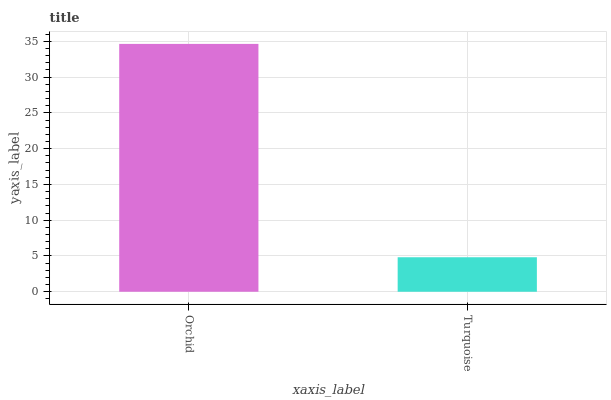Is Turquoise the minimum?
Answer yes or no. Yes. Is Orchid the maximum?
Answer yes or no. Yes. Is Turquoise the maximum?
Answer yes or no. No. Is Orchid greater than Turquoise?
Answer yes or no. Yes. Is Turquoise less than Orchid?
Answer yes or no. Yes. Is Turquoise greater than Orchid?
Answer yes or no. No. Is Orchid less than Turquoise?
Answer yes or no. No. Is Orchid the high median?
Answer yes or no. Yes. Is Turquoise the low median?
Answer yes or no. Yes. Is Turquoise the high median?
Answer yes or no. No. Is Orchid the low median?
Answer yes or no. No. 